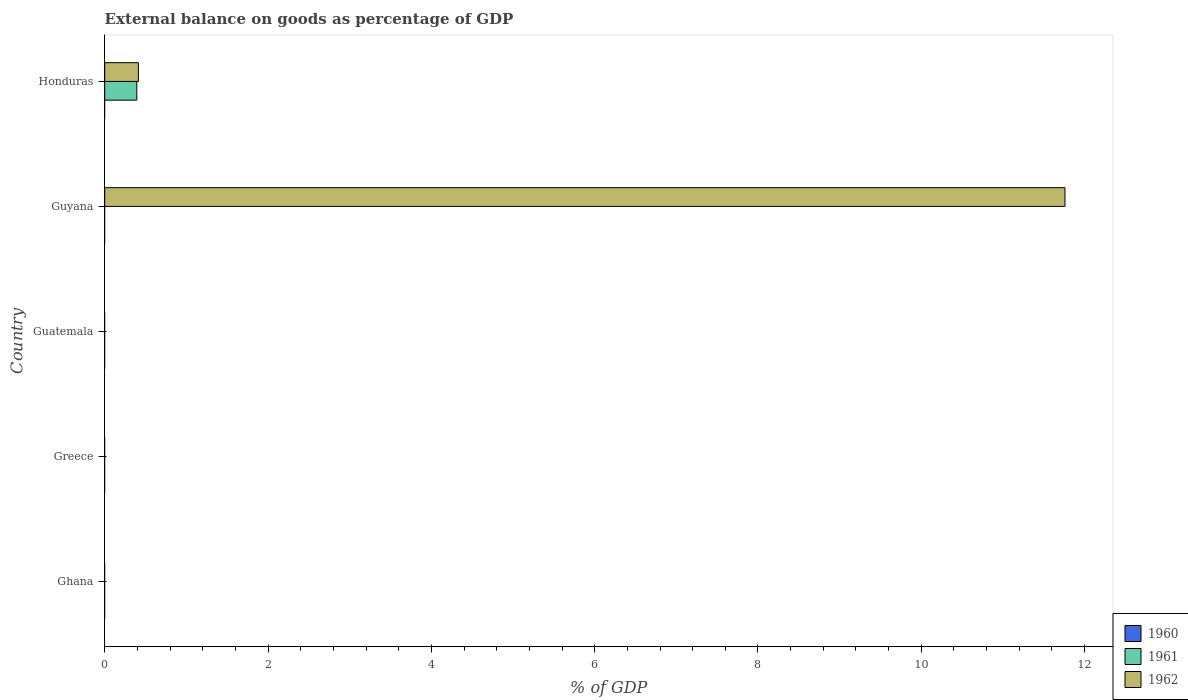How many different coloured bars are there?
Offer a terse response. 2. What is the label of the 5th group of bars from the top?
Give a very brief answer. Ghana. In how many cases, is the number of bars for a given country not equal to the number of legend labels?
Keep it short and to the point. 5. What is the external balance on goods as percentage of GDP in 1961 in Guyana?
Provide a short and direct response. 0. Across all countries, what is the maximum external balance on goods as percentage of GDP in 1961?
Ensure brevity in your answer.  0.39. In which country was the external balance on goods as percentage of GDP in 1962 maximum?
Offer a very short reply. Guyana. What is the difference between the external balance on goods as percentage of GDP in 1962 in Guyana and that in Honduras?
Ensure brevity in your answer.  11.35. What is the difference between the external balance on goods as percentage of GDP in 1961 in Guatemala and the external balance on goods as percentage of GDP in 1962 in Honduras?
Offer a terse response. -0.41. What is the average external balance on goods as percentage of GDP in 1961 per country?
Offer a terse response. 0.08. What is the difference between the external balance on goods as percentage of GDP in 1961 and external balance on goods as percentage of GDP in 1962 in Honduras?
Your response must be concise. -0.02. In how many countries, is the external balance on goods as percentage of GDP in 1962 greater than 4.4 %?
Your answer should be compact. 1. What is the difference between the highest and the lowest external balance on goods as percentage of GDP in 1962?
Your answer should be very brief. 11.76. In how many countries, is the external balance on goods as percentage of GDP in 1962 greater than the average external balance on goods as percentage of GDP in 1962 taken over all countries?
Make the answer very short. 1. Is it the case that in every country, the sum of the external balance on goods as percentage of GDP in 1961 and external balance on goods as percentage of GDP in 1960 is greater than the external balance on goods as percentage of GDP in 1962?
Your response must be concise. No. How many bars are there?
Make the answer very short. 3. Are all the bars in the graph horizontal?
Provide a succinct answer. Yes. How many countries are there in the graph?
Provide a short and direct response. 5. Does the graph contain grids?
Your response must be concise. No. Where does the legend appear in the graph?
Give a very brief answer. Bottom right. What is the title of the graph?
Provide a short and direct response. External balance on goods as percentage of GDP. Does "1994" appear as one of the legend labels in the graph?
Offer a very short reply. No. What is the label or title of the X-axis?
Your answer should be compact. % of GDP. What is the % of GDP in 1960 in Ghana?
Your answer should be compact. 0. What is the % of GDP of 1961 in Ghana?
Provide a short and direct response. 0. What is the % of GDP of 1961 in Greece?
Your response must be concise. 0. What is the % of GDP of 1960 in Guatemala?
Offer a terse response. 0. What is the % of GDP in 1961 in Guatemala?
Your response must be concise. 0. What is the % of GDP in 1960 in Guyana?
Make the answer very short. 0. What is the % of GDP in 1961 in Guyana?
Offer a very short reply. 0. What is the % of GDP of 1962 in Guyana?
Provide a succinct answer. 11.76. What is the % of GDP of 1961 in Honduras?
Offer a terse response. 0.39. What is the % of GDP of 1962 in Honduras?
Your response must be concise. 0.41. Across all countries, what is the maximum % of GDP in 1961?
Provide a short and direct response. 0.39. Across all countries, what is the maximum % of GDP in 1962?
Your response must be concise. 11.76. Across all countries, what is the minimum % of GDP of 1962?
Offer a terse response. 0. What is the total % of GDP of 1961 in the graph?
Provide a succinct answer. 0.39. What is the total % of GDP of 1962 in the graph?
Your response must be concise. 12.17. What is the difference between the % of GDP of 1962 in Guyana and that in Honduras?
Your answer should be very brief. 11.35. What is the average % of GDP of 1960 per country?
Keep it short and to the point. 0. What is the average % of GDP in 1961 per country?
Provide a succinct answer. 0.08. What is the average % of GDP of 1962 per country?
Your response must be concise. 2.43. What is the difference between the % of GDP of 1961 and % of GDP of 1962 in Honduras?
Ensure brevity in your answer.  -0.02. What is the ratio of the % of GDP of 1962 in Guyana to that in Honduras?
Your answer should be compact. 28.5. What is the difference between the highest and the lowest % of GDP of 1961?
Ensure brevity in your answer.  0.39. What is the difference between the highest and the lowest % of GDP in 1962?
Your answer should be compact. 11.76. 